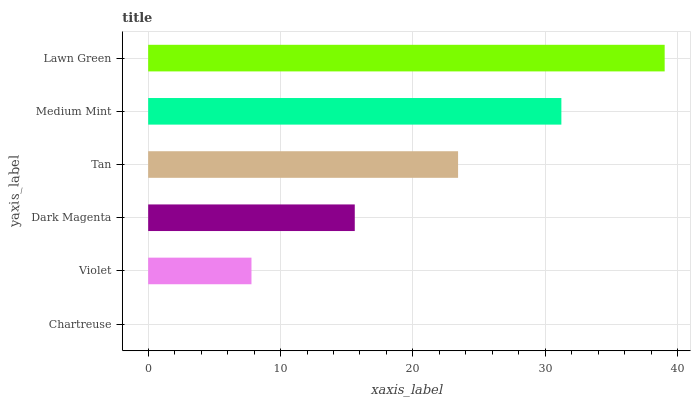Is Chartreuse the minimum?
Answer yes or no. Yes. Is Lawn Green the maximum?
Answer yes or no. Yes. Is Violet the minimum?
Answer yes or no. No. Is Violet the maximum?
Answer yes or no. No. Is Violet greater than Chartreuse?
Answer yes or no. Yes. Is Chartreuse less than Violet?
Answer yes or no. Yes. Is Chartreuse greater than Violet?
Answer yes or no. No. Is Violet less than Chartreuse?
Answer yes or no. No. Is Tan the high median?
Answer yes or no. Yes. Is Dark Magenta the low median?
Answer yes or no. Yes. Is Medium Mint the high median?
Answer yes or no. No. Is Chartreuse the low median?
Answer yes or no. No. 